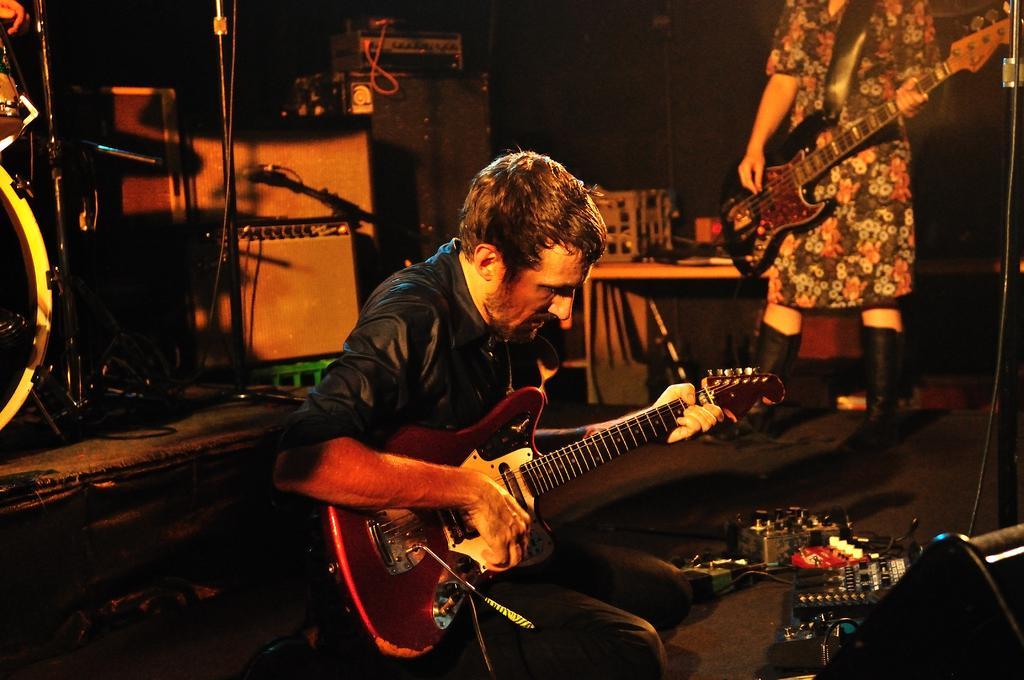How would you summarize this image in a sentence or two? In this picture there is a man who is sitting on the chair and playing a guitar. In front of him I can see the amplifiers and other electronic equipment. On the right there is a woman who is holding a guitar. Behind I can see some objects on the table. On the left I can see the drums, mics and other objects. 